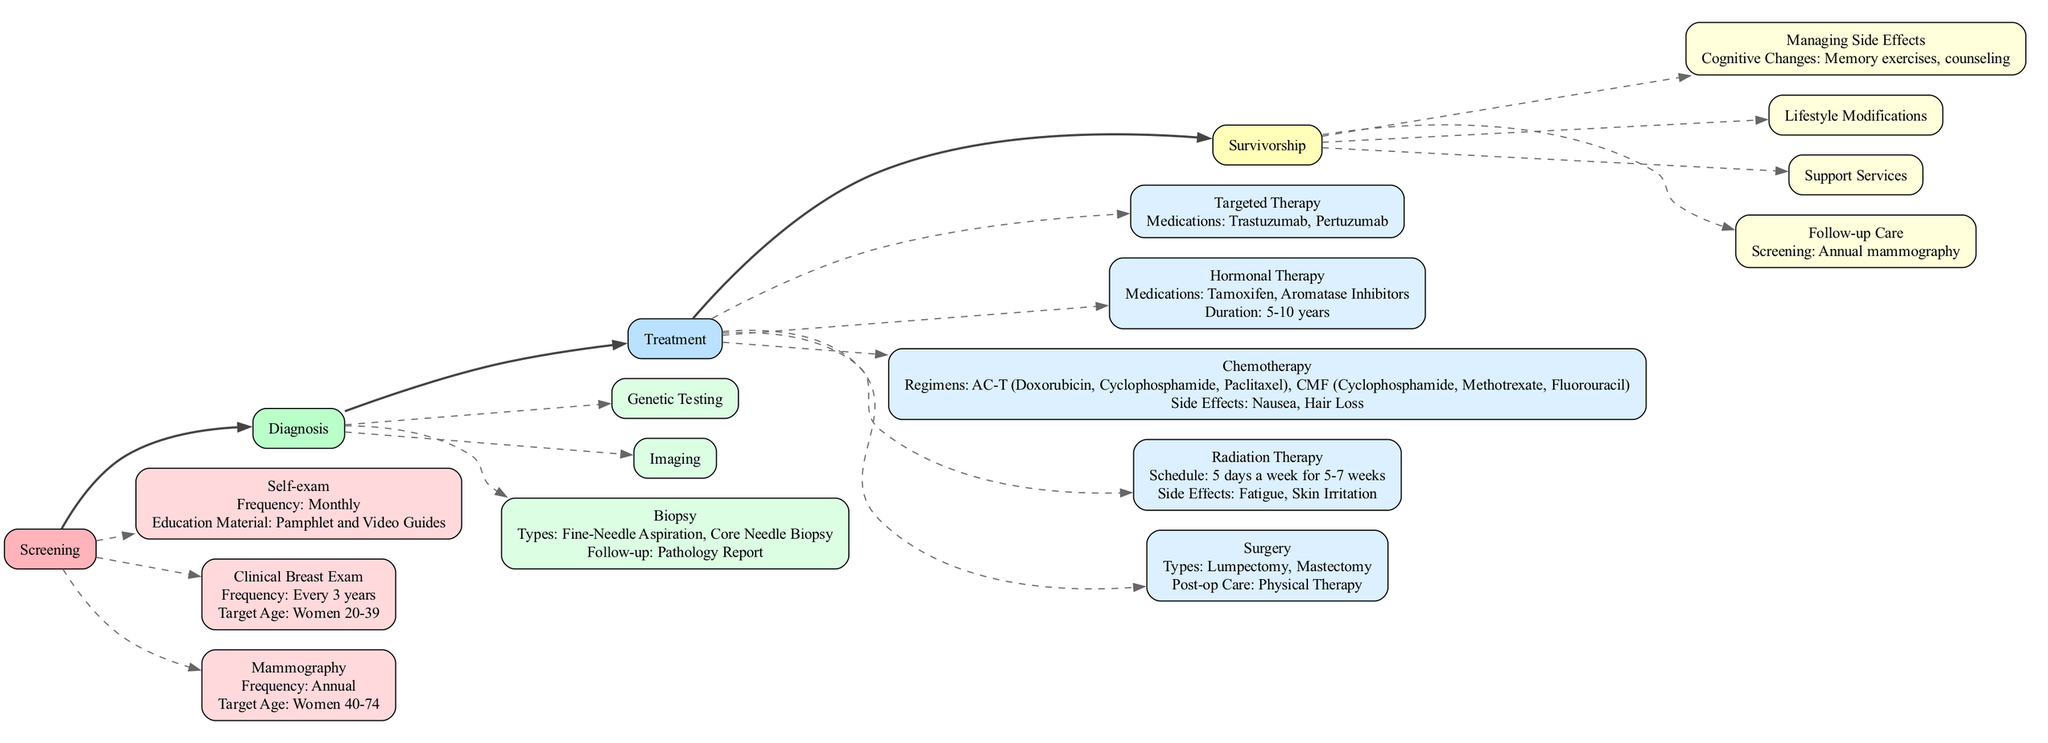What is the target age for mammography screening? The diagram indicates that mammography screening targets women aged 40 to 74. This is explicitly mentioned under the "Mammography" node in the "Screening" stage.
Answer: Women 40-74 How often should self-exams be conducted? The diagram specifies that self-exams should be performed monthly. This information can be found in the "Self-exam" node in the "Screening" stage.
Answer: Monthly What is one follow-up procedure after a biopsy? According to the diagram, the follow-up after any type of biopsy is to receive a pathology report. This is directly stated in the "Biopsy" node under the "Diagnosis" stage.
Answer: Pathology Report What are the types of surgery listed for breast cancer treatment? The diagram lists two types of surgeries: Lumpectomy and Mastectomy. This can be found in the "Surgery" node in the "Treatment" stage, which details each type.
Answer: Lumpectomy, Mastectomy How many different types of chemotherapy regimens are shown? The diagram shows two chemotherapy regimens: AC-T (Doxorubicin, Cyclophosphamide, Paclitaxel) and CMF (Cyclophosphamide, Methotrexate, Fluorouracil). This can be counted under the "Chemotherapy" node in the "Treatment" stage.
Answer: 2 What is the frequency of clinical visits during survivorship care? The diagram states that clinical visits should occur every 3-6 months for the first two years, followed by annual visits. This detail is found in the "Follow-up Care" section of the "Survivorship" stage.
Answer: Every 3-6 months for the first 2 years, then annually What support services are provided during survivorship? The diagram indicates that counseling and support groups are available as support services for survivorship. This is explicitly found in the "Support Services" node in the "Survivorship" section.
Answer: Counseling, Support Groups Which hormone therapy medications are mentioned? The diagram lists Tamoxifen and Aromatase Inhibitors as hormonal therapy medications. This information is found under the "Hormonal Therapy" node in the "Treatment" stage.
Answer: Tamoxifen, Aromatase Inhibitors What lifestyle modification is recommended regarding diet? The diagram suggests a diet high in fruits and vegetables and low in processed foods. This information can be found in the "Lifestyle Modifications" section under "Survivorship."
Answer: High in fruits and vegetables, low in processed foods 